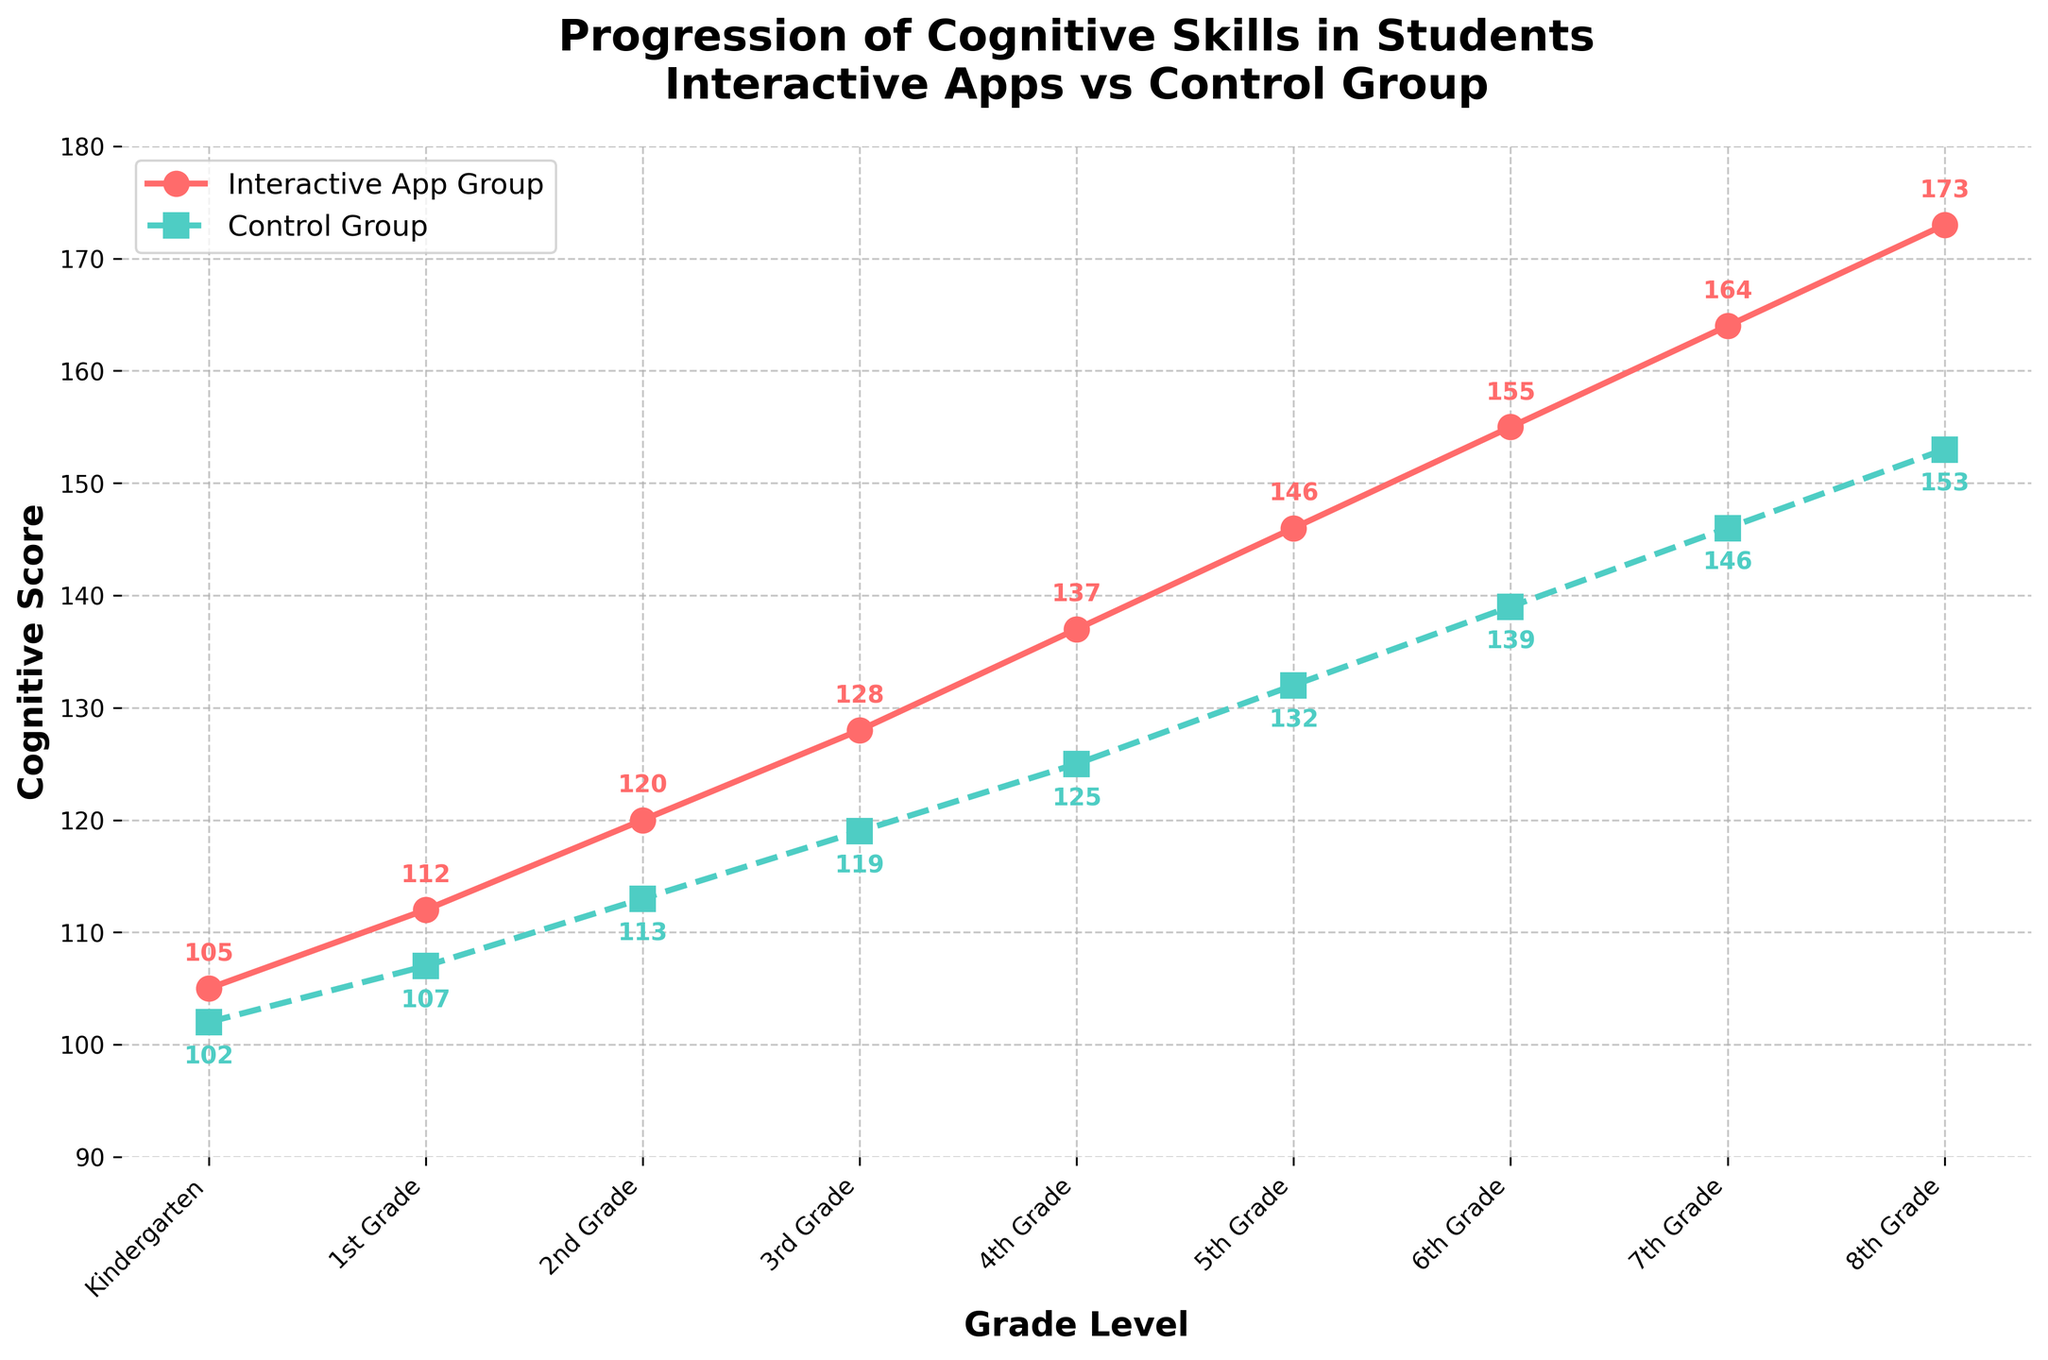What is the difference in cognitive scores between the Interactive App Group and the Control Group for 3rd Grade? The cognitive score for the Interactive App Group in 3rd Grade is 128, and for the Control Group, it is 119. The difference is 128 - 119.
Answer: 9 Which group shows higher cognitive scores in 5th Grade? By examining the cognitive scores for 5th Grade, the Interactive App Group has a score of 146, while the Control Group has a score of 132. 146 is greater than 132.
Answer: Interactive App Group In which grade level does the largest difference in cognitive scores between the two groups occur? Calculating the differences for each grade level: Kindergarten (3), 1st Grade (5), 2nd Grade (7), 3rd Grade (9), 4th Grade (12), 5th Grade (14), 6th Grade (16), 7th Grade (18), and 8th Grade (20). The largest difference is 20 in 8th Grade.
Answer: 8th Grade What are the average cognitive scores for the Interactive App Group and the Control Group across all grade levels? Sum the Interactive App Group scores (105+112+120+128+137+146+155+164+173) and divide by 9. Sum the Control Group scores (102+107+113+119+125+132+139+146+153) and divide by 9.
Answer: Interactive App Group: 137, Control Group: 126 By how much do cognitive scores increase from Kindergarten to 8th Grade in the Interactive App Group? Calculate the increase by subtracting the Kindergarten score (105) from the 8th Grade score (173) in the Interactive App Group. 173 - 105.
Answer: 68 In which grade do both groups' cognitive scores first exceed 130? Checking each grade level: Interactive App Group exceeds 130 in 4th Grade with a score of 137, and the Control Group exceeds 130 in 5th Grade with a score of 132.
Answer: 5th Grade What is the trend for cognitive scores in both groups across the grade levels? The trend in the graph shows that cognitive scores for both groups increase steadily as the grade level increases.
Answer: Increasing Which grade level shows the smallest difference in cognitive scores between the two groups? Differences in scores: Kindergarten (3), 1st Grade (5), 2nd Grade (7), 3rd Grade (9), 4th Grade (12), 5th Grade (14), 6th Grade (16), 7th Grade (18), 8th Grade (20). The smallest difference is 3 in Kindergarten.
Answer: Kindergarten What color represents the Interactive App Group in the figure? Observing the plotted lines and the legend, the Interactive App Group is represented by the red line with circle markers.
Answer: Red What is the slope of the trend line for the Interactive App Group from 1st Grade to 3rd Grade? Calculate the slope by taking the difference in scores from 3rd Grade (128) to 1st Grade (112) and dividing by the grade difference (3-1). Slope = (128 - 112) / (3 - 1)
Answer: 8 